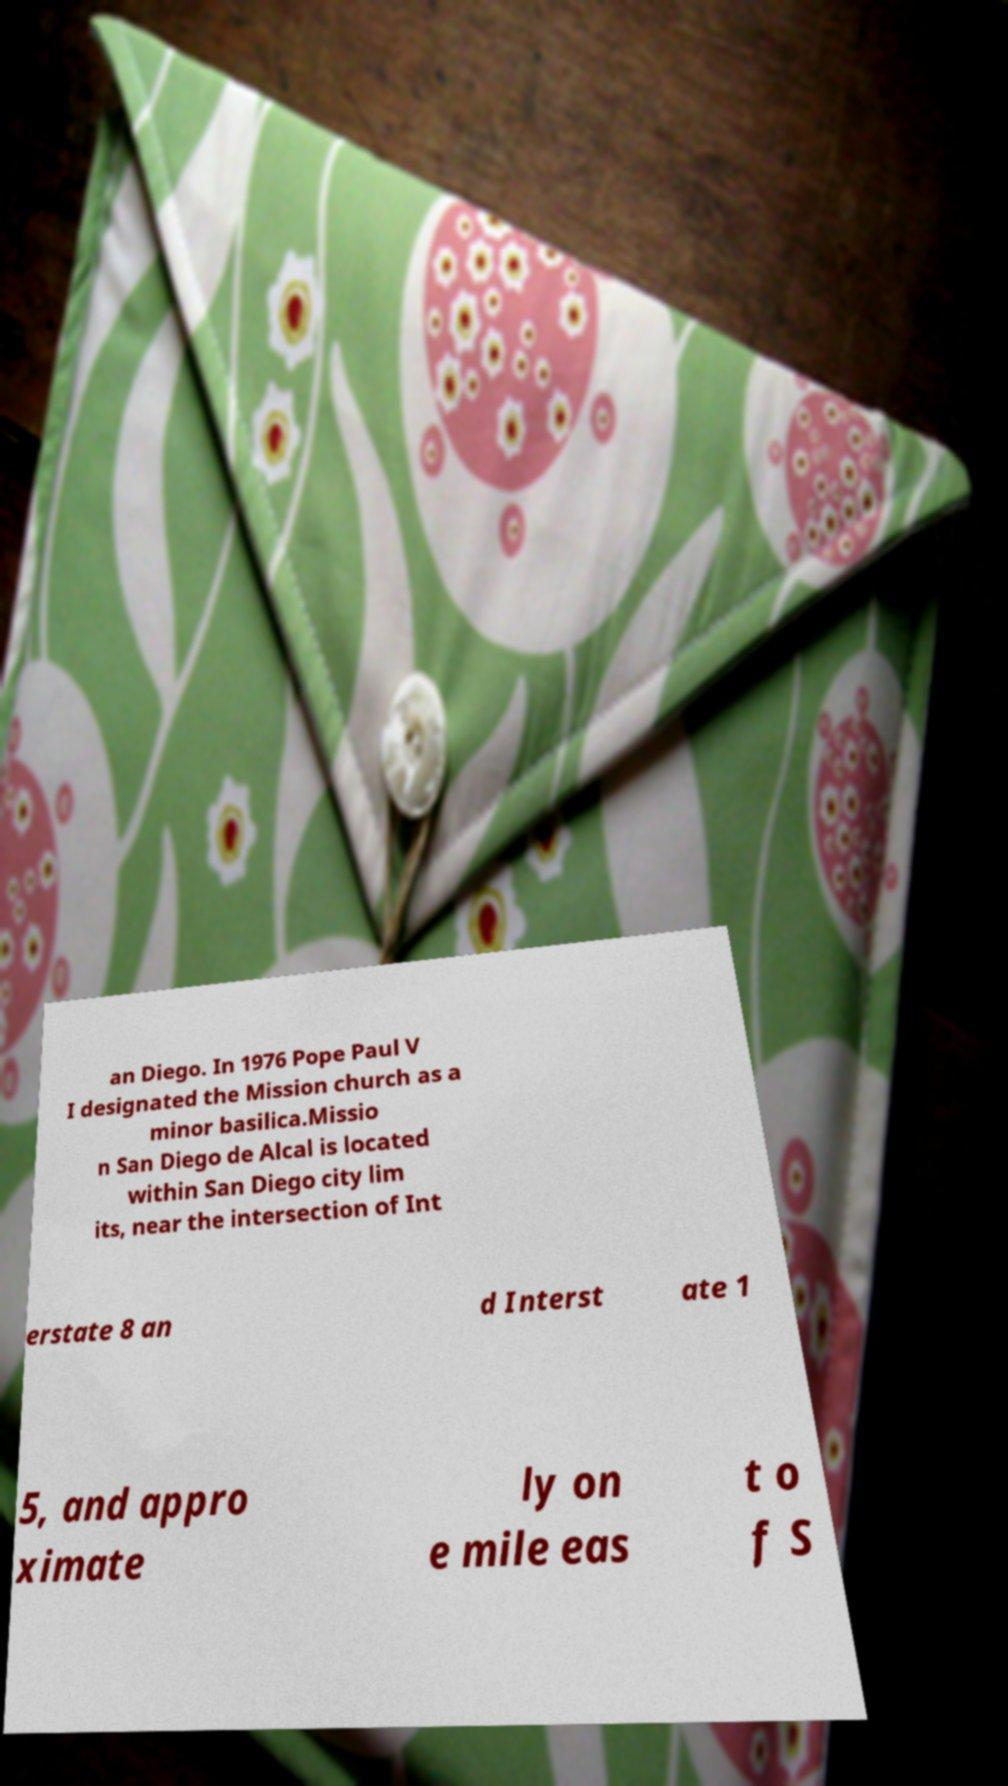Please read and relay the text visible in this image. What does it say? an Diego. In 1976 Pope Paul V I designated the Mission church as a minor basilica.Missio n San Diego de Alcal is located within San Diego city lim its, near the intersection of Int erstate 8 an d Interst ate 1 5, and appro ximate ly on e mile eas t o f S 